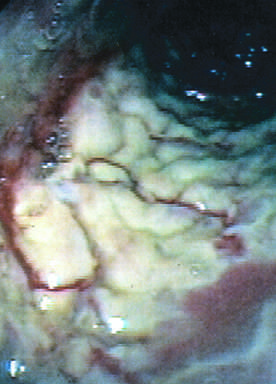s a pacemaker coated by tan pseudomembranes composed of neutrophils, dead epithelial cells, and inflammatory debris endoscopic view?
Answer the question using a single word or phrase. No 